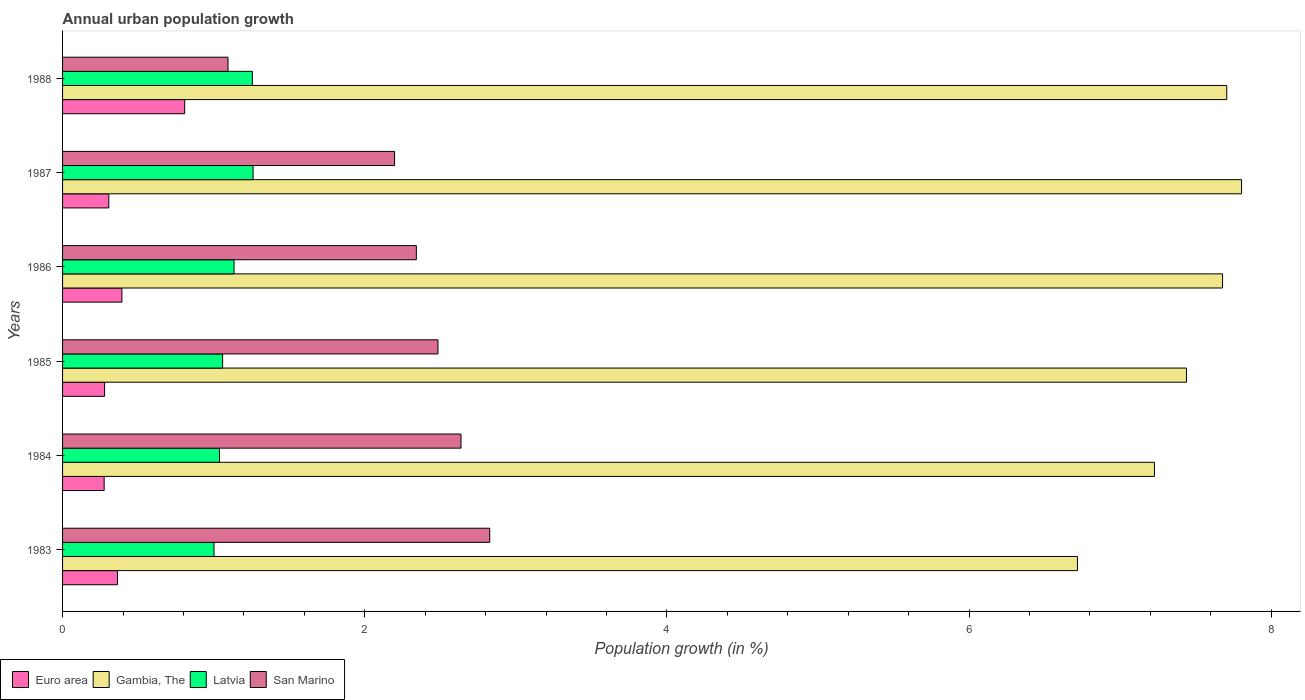How many groups of bars are there?
Keep it short and to the point. 6. Are the number of bars per tick equal to the number of legend labels?
Provide a short and direct response. Yes. Are the number of bars on each tick of the Y-axis equal?
Offer a terse response. Yes. How many bars are there on the 6th tick from the bottom?
Your answer should be very brief. 4. In how many cases, is the number of bars for a given year not equal to the number of legend labels?
Your response must be concise. 0. What is the percentage of urban population growth in Latvia in 1988?
Provide a succinct answer. 1.26. Across all years, what is the maximum percentage of urban population growth in Latvia?
Give a very brief answer. 1.26. Across all years, what is the minimum percentage of urban population growth in Euro area?
Give a very brief answer. 0.28. In which year was the percentage of urban population growth in San Marino maximum?
Provide a succinct answer. 1983. What is the total percentage of urban population growth in Euro area in the graph?
Provide a short and direct response. 2.42. What is the difference between the percentage of urban population growth in Euro area in 1983 and that in 1986?
Make the answer very short. -0.03. What is the difference between the percentage of urban population growth in Gambia, The in 1987 and the percentage of urban population growth in San Marino in 1988?
Ensure brevity in your answer.  6.71. What is the average percentage of urban population growth in Latvia per year?
Offer a terse response. 1.13. In the year 1985, what is the difference between the percentage of urban population growth in Gambia, The and percentage of urban population growth in Euro area?
Make the answer very short. 7.16. In how many years, is the percentage of urban population growth in Latvia greater than 7.6 %?
Offer a very short reply. 0. What is the ratio of the percentage of urban population growth in Gambia, The in 1986 to that in 1988?
Your answer should be compact. 1. What is the difference between the highest and the second highest percentage of urban population growth in Latvia?
Offer a very short reply. 0. What is the difference between the highest and the lowest percentage of urban population growth in San Marino?
Provide a succinct answer. 1.73. In how many years, is the percentage of urban population growth in Gambia, The greater than the average percentage of urban population growth in Gambia, The taken over all years?
Ensure brevity in your answer.  4. Is the sum of the percentage of urban population growth in San Marino in 1983 and 1984 greater than the maximum percentage of urban population growth in Euro area across all years?
Make the answer very short. Yes. What does the 2nd bar from the top in 1983 represents?
Keep it short and to the point. Latvia. What does the 3rd bar from the bottom in 1987 represents?
Your response must be concise. Latvia. How many bars are there?
Provide a succinct answer. 24. Are all the bars in the graph horizontal?
Your answer should be compact. Yes. How many years are there in the graph?
Keep it short and to the point. 6. What is the difference between two consecutive major ticks on the X-axis?
Give a very brief answer. 2. Are the values on the major ticks of X-axis written in scientific E-notation?
Your answer should be compact. No. Does the graph contain grids?
Your answer should be very brief. No. How many legend labels are there?
Offer a terse response. 4. What is the title of the graph?
Keep it short and to the point. Annual urban population growth. What is the label or title of the X-axis?
Your answer should be compact. Population growth (in %). What is the Population growth (in %) in Euro area in 1983?
Your response must be concise. 0.36. What is the Population growth (in %) in Gambia, The in 1983?
Provide a succinct answer. 6.72. What is the Population growth (in %) in Latvia in 1983?
Your answer should be compact. 1. What is the Population growth (in %) in San Marino in 1983?
Your answer should be compact. 2.83. What is the Population growth (in %) in Euro area in 1984?
Your answer should be compact. 0.28. What is the Population growth (in %) of Gambia, The in 1984?
Give a very brief answer. 7.23. What is the Population growth (in %) of Latvia in 1984?
Provide a succinct answer. 1.04. What is the Population growth (in %) in San Marino in 1984?
Your answer should be compact. 2.64. What is the Population growth (in %) in Euro area in 1985?
Your answer should be compact. 0.28. What is the Population growth (in %) of Gambia, The in 1985?
Provide a short and direct response. 7.44. What is the Population growth (in %) of Latvia in 1985?
Make the answer very short. 1.06. What is the Population growth (in %) in San Marino in 1985?
Your answer should be compact. 2.48. What is the Population growth (in %) of Euro area in 1986?
Make the answer very short. 0.39. What is the Population growth (in %) of Gambia, The in 1986?
Ensure brevity in your answer.  7.68. What is the Population growth (in %) of Latvia in 1986?
Ensure brevity in your answer.  1.14. What is the Population growth (in %) in San Marino in 1986?
Your answer should be very brief. 2.34. What is the Population growth (in %) of Euro area in 1987?
Provide a short and direct response. 0.31. What is the Population growth (in %) of Gambia, The in 1987?
Keep it short and to the point. 7.8. What is the Population growth (in %) in Latvia in 1987?
Make the answer very short. 1.26. What is the Population growth (in %) of San Marino in 1987?
Keep it short and to the point. 2.2. What is the Population growth (in %) in Euro area in 1988?
Offer a very short reply. 0.81. What is the Population growth (in %) of Gambia, The in 1988?
Your answer should be compact. 7.71. What is the Population growth (in %) in Latvia in 1988?
Your response must be concise. 1.26. What is the Population growth (in %) of San Marino in 1988?
Keep it short and to the point. 1.1. Across all years, what is the maximum Population growth (in %) of Euro area?
Your response must be concise. 0.81. Across all years, what is the maximum Population growth (in %) in Gambia, The?
Provide a succinct answer. 7.8. Across all years, what is the maximum Population growth (in %) in Latvia?
Provide a short and direct response. 1.26. Across all years, what is the maximum Population growth (in %) of San Marino?
Keep it short and to the point. 2.83. Across all years, what is the minimum Population growth (in %) of Euro area?
Give a very brief answer. 0.28. Across all years, what is the minimum Population growth (in %) in Gambia, The?
Provide a short and direct response. 6.72. Across all years, what is the minimum Population growth (in %) of Latvia?
Your answer should be compact. 1. Across all years, what is the minimum Population growth (in %) in San Marino?
Your answer should be compact. 1.1. What is the total Population growth (in %) of Euro area in the graph?
Your answer should be compact. 2.42. What is the total Population growth (in %) of Gambia, The in the graph?
Your answer should be compact. 44.57. What is the total Population growth (in %) of Latvia in the graph?
Keep it short and to the point. 6.75. What is the total Population growth (in %) in San Marino in the graph?
Offer a terse response. 13.58. What is the difference between the Population growth (in %) of Euro area in 1983 and that in 1984?
Offer a very short reply. 0.09. What is the difference between the Population growth (in %) in Gambia, The in 1983 and that in 1984?
Ensure brevity in your answer.  -0.51. What is the difference between the Population growth (in %) in Latvia in 1983 and that in 1984?
Your answer should be compact. -0.04. What is the difference between the Population growth (in %) of San Marino in 1983 and that in 1984?
Provide a succinct answer. 0.19. What is the difference between the Population growth (in %) in Euro area in 1983 and that in 1985?
Your answer should be very brief. 0.09. What is the difference between the Population growth (in %) of Gambia, The in 1983 and that in 1985?
Offer a terse response. -0.72. What is the difference between the Population growth (in %) in Latvia in 1983 and that in 1985?
Your response must be concise. -0.06. What is the difference between the Population growth (in %) in San Marino in 1983 and that in 1985?
Provide a succinct answer. 0.34. What is the difference between the Population growth (in %) in Euro area in 1983 and that in 1986?
Offer a very short reply. -0.03. What is the difference between the Population growth (in %) of Gambia, The in 1983 and that in 1986?
Keep it short and to the point. -0.96. What is the difference between the Population growth (in %) of Latvia in 1983 and that in 1986?
Your response must be concise. -0.13. What is the difference between the Population growth (in %) in San Marino in 1983 and that in 1986?
Offer a terse response. 0.49. What is the difference between the Population growth (in %) of Euro area in 1983 and that in 1987?
Offer a terse response. 0.06. What is the difference between the Population growth (in %) in Gambia, The in 1983 and that in 1987?
Your answer should be compact. -1.09. What is the difference between the Population growth (in %) in Latvia in 1983 and that in 1987?
Keep it short and to the point. -0.26. What is the difference between the Population growth (in %) in San Marino in 1983 and that in 1987?
Provide a succinct answer. 0.63. What is the difference between the Population growth (in %) in Euro area in 1983 and that in 1988?
Keep it short and to the point. -0.44. What is the difference between the Population growth (in %) in Gambia, The in 1983 and that in 1988?
Ensure brevity in your answer.  -0.99. What is the difference between the Population growth (in %) of Latvia in 1983 and that in 1988?
Give a very brief answer. -0.25. What is the difference between the Population growth (in %) in San Marino in 1983 and that in 1988?
Provide a short and direct response. 1.73. What is the difference between the Population growth (in %) of Euro area in 1984 and that in 1985?
Your response must be concise. -0. What is the difference between the Population growth (in %) of Gambia, The in 1984 and that in 1985?
Your response must be concise. -0.21. What is the difference between the Population growth (in %) in Latvia in 1984 and that in 1985?
Your answer should be compact. -0.02. What is the difference between the Population growth (in %) in San Marino in 1984 and that in 1985?
Your response must be concise. 0.15. What is the difference between the Population growth (in %) in Euro area in 1984 and that in 1986?
Provide a short and direct response. -0.12. What is the difference between the Population growth (in %) of Gambia, The in 1984 and that in 1986?
Your answer should be very brief. -0.45. What is the difference between the Population growth (in %) in Latvia in 1984 and that in 1986?
Keep it short and to the point. -0.1. What is the difference between the Population growth (in %) of San Marino in 1984 and that in 1986?
Ensure brevity in your answer.  0.3. What is the difference between the Population growth (in %) of Euro area in 1984 and that in 1987?
Provide a succinct answer. -0.03. What is the difference between the Population growth (in %) in Gambia, The in 1984 and that in 1987?
Ensure brevity in your answer.  -0.58. What is the difference between the Population growth (in %) in Latvia in 1984 and that in 1987?
Provide a short and direct response. -0.22. What is the difference between the Population growth (in %) in San Marino in 1984 and that in 1987?
Give a very brief answer. 0.44. What is the difference between the Population growth (in %) of Euro area in 1984 and that in 1988?
Your answer should be compact. -0.53. What is the difference between the Population growth (in %) in Gambia, The in 1984 and that in 1988?
Ensure brevity in your answer.  -0.48. What is the difference between the Population growth (in %) of Latvia in 1984 and that in 1988?
Give a very brief answer. -0.22. What is the difference between the Population growth (in %) in San Marino in 1984 and that in 1988?
Offer a terse response. 1.54. What is the difference between the Population growth (in %) of Euro area in 1985 and that in 1986?
Your response must be concise. -0.11. What is the difference between the Population growth (in %) in Gambia, The in 1985 and that in 1986?
Offer a terse response. -0.24. What is the difference between the Population growth (in %) of Latvia in 1985 and that in 1986?
Give a very brief answer. -0.08. What is the difference between the Population growth (in %) in San Marino in 1985 and that in 1986?
Your answer should be compact. 0.14. What is the difference between the Population growth (in %) of Euro area in 1985 and that in 1987?
Your answer should be very brief. -0.03. What is the difference between the Population growth (in %) of Gambia, The in 1985 and that in 1987?
Offer a very short reply. -0.36. What is the difference between the Population growth (in %) in Latvia in 1985 and that in 1987?
Your answer should be very brief. -0.2. What is the difference between the Population growth (in %) of San Marino in 1985 and that in 1987?
Provide a succinct answer. 0.29. What is the difference between the Population growth (in %) in Euro area in 1985 and that in 1988?
Keep it short and to the point. -0.53. What is the difference between the Population growth (in %) in Gambia, The in 1985 and that in 1988?
Offer a very short reply. -0.27. What is the difference between the Population growth (in %) of Latvia in 1985 and that in 1988?
Your answer should be very brief. -0.2. What is the difference between the Population growth (in %) in San Marino in 1985 and that in 1988?
Provide a short and direct response. 1.39. What is the difference between the Population growth (in %) in Euro area in 1986 and that in 1987?
Offer a very short reply. 0.09. What is the difference between the Population growth (in %) of Gambia, The in 1986 and that in 1987?
Your answer should be very brief. -0.13. What is the difference between the Population growth (in %) in Latvia in 1986 and that in 1987?
Make the answer very short. -0.13. What is the difference between the Population growth (in %) in San Marino in 1986 and that in 1987?
Your response must be concise. 0.14. What is the difference between the Population growth (in %) of Euro area in 1986 and that in 1988?
Keep it short and to the point. -0.42. What is the difference between the Population growth (in %) of Gambia, The in 1986 and that in 1988?
Ensure brevity in your answer.  -0.03. What is the difference between the Population growth (in %) of Latvia in 1986 and that in 1988?
Make the answer very short. -0.12. What is the difference between the Population growth (in %) in San Marino in 1986 and that in 1988?
Make the answer very short. 1.25. What is the difference between the Population growth (in %) of Euro area in 1987 and that in 1988?
Keep it short and to the point. -0.5. What is the difference between the Population growth (in %) of Gambia, The in 1987 and that in 1988?
Offer a terse response. 0.1. What is the difference between the Population growth (in %) of Latvia in 1987 and that in 1988?
Your answer should be very brief. 0. What is the difference between the Population growth (in %) in San Marino in 1987 and that in 1988?
Offer a terse response. 1.1. What is the difference between the Population growth (in %) in Euro area in 1983 and the Population growth (in %) in Gambia, The in 1984?
Your answer should be compact. -6.86. What is the difference between the Population growth (in %) in Euro area in 1983 and the Population growth (in %) in Latvia in 1984?
Give a very brief answer. -0.68. What is the difference between the Population growth (in %) of Euro area in 1983 and the Population growth (in %) of San Marino in 1984?
Provide a short and direct response. -2.27. What is the difference between the Population growth (in %) of Gambia, The in 1983 and the Population growth (in %) of Latvia in 1984?
Give a very brief answer. 5.68. What is the difference between the Population growth (in %) of Gambia, The in 1983 and the Population growth (in %) of San Marino in 1984?
Your answer should be very brief. 4.08. What is the difference between the Population growth (in %) of Latvia in 1983 and the Population growth (in %) of San Marino in 1984?
Your answer should be very brief. -1.63. What is the difference between the Population growth (in %) of Euro area in 1983 and the Population growth (in %) of Gambia, The in 1985?
Offer a very short reply. -7.08. What is the difference between the Population growth (in %) in Euro area in 1983 and the Population growth (in %) in Latvia in 1985?
Ensure brevity in your answer.  -0.7. What is the difference between the Population growth (in %) of Euro area in 1983 and the Population growth (in %) of San Marino in 1985?
Give a very brief answer. -2.12. What is the difference between the Population growth (in %) in Gambia, The in 1983 and the Population growth (in %) in Latvia in 1985?
Make the answer very short. 5.66. What is the difference between the Population growth (in %) of Gambia, The in 1983 and the Population growth (in %) of San Marino in 1985?
Ensure brevity in your answer.  4.23. What is the difference between the Population growth (in %) of Latvia in 1983 and the Population growth (in %) of San Marino in 1985?
Your answer should be compact. -1.48. What is the difference between the Population growth (in %) of Euro area in 1983 and the Population growth (in %) of Gambia, The in 1986?
Give a very brief answer. -7.31. What is the difference between the Population growth (in %) of Euro area in 1983 and the Population growth (in %) of Latvia in 1986?
Ensure brevity in your answer.  -0.77. What is the difference between the Population growth (in %) of Euro area in 1983 and the Population growth (in %) of San Marino in 1986?
Your answer should be very brief. -1.98. What is the difference between the Population growth (in %) of Gambia, The in 1983 and the Population growth (in %) of Latvia in 1986?
Your response must be concise. 5.58. What is the difference between the Population growth (in %) of Gambia, The in 1983 and the Population growth (in %) of San Marino in 1986?
Your answer should be very brief. 4.38. What is the difference between the Population growth (in %) of Latvia in 1983 and the Population growth (in %) of San Marino in 1986?
Make the answer very short. -1.34. What is the difference between the Population growth (in %) of Euro area in 1983 and the Population growth (in %) of Gambia, The in 1987?
Give a very brief answer. -7.44. What is the difference between the Population growth (in %) of Euro area in 1983 and the Population growth (in %) of Latvia in 1987?
Keep it short and to the point. -0.9. What is the difference between the Population growth (in %) in Euro area in 1983 and the Population growth (in %) in San Marino in 1987?
Provide a short and direct response. -1.83. What is the difference between the Population growth (in %) of Gambia, The in 1983 and the Population growth (in %) of Latvia in 1987?
Provide a short and direct response. 5.46. What is the difference between the Population growth (in %) of Gambia, The in 1983 and the Population growth (in %) of San Marino in 1987?
Your answer should be compact. 4.52. What is the difference between the Population growth (in %) of Latvia in 1983 and the Population growth (in %) of San Marino in 1987?
Provide a succinct answer. -1.2. What is the difference between the Population growth (in %) in Euro area in 1983 and the Population growth (in %) in Gambia, The in 1988?
Ensure brevity in your answer.  -7.34. What is the difference between the Population growth (in %) in Euro area in 1983 and the Population growth (in %) in Latvia in 1988?
Provide a succinct answer. -0.89. What is the difference between the Population growth (in %) in Euro area in 1983 and the Population growth (in %) in San Marino in 1988?
Provide a short and direct response. -0.73. What is the difference between the Population growth (in %) in Gambia, The in 1983 and the Population growth (in %) in Latvia in 1988?
Your response must be concise. 5.46. What is the difference between the Population growth (in %) of Gambia, The in 1983 and the Population growth (in %) of San Marino in 1988?
Keep it short and to the point. 5.62. What is the difference between the Population growth (in %) in Latvia in 1983 and the Population growth (in %) in San Marino in 1988?
Offer a terse response. -0.09. What is the difference between the Population growth (in %) in Euro area in 1984 and the Population growth (in %) in Gambia, The in 1985?
Offer a terse response. -7.16. What is the difference between the Population growth (in %) in Euro area in 1984 and the Population growth (in %) in Latvia in 1985?
Provide a short and direct response. -0.78. What is the difference between the Population growth (in %) in Euro area in 1984 and the Population growth (in %) in San Marino in 1985?
Your answer should be compact. -2.21. What is the difference between the Population growth (in %) in Gambia, The in 1984 and the Population growth (in %) in Latvia in 1985?
Your response must be concise. 6.17. What is the difference between the Population growth (in %) in Gambia, The in 1984 and the Population growth (in %) in San Marino in 1985?
Your response must be concise. 4.74. What is the difference between the Population growth (in %) of Latvia in 1984 and the Population growth (in %) of San Marino in 1985?
Offer a terse response. -1.45. What is the difference between the Population growth (in %) in Euro area in 1984 and the Population growth (in %) in Gambia, The in 1986?
Give a very brief answer. -7.4. What is the difference between the Population growth (in %) in Euro area in 1984 and the Population growth (in %) in Latvia in 1986?
Offer a terse response. -0.86. What is the difference between the Population growth (in %) in Euro area in 1984 and the Population growth (in %) in San Marino in 1986?
Your response must be concise. -2.07. What is the difference between the Population growth (in %) of Gambia, The in 1984 and the Population growth (in %) of Latvia in 1986?
Give a very brief answer. 6.09. What is the difference between the Population growth (in %) in Gambia, The in 1984 and the Population growth (in %) in San Marino in 1986?
Make the answer very short. 4.89. What is the difference between the Population growth (in %) of Latvia in 1984 and the Population growth (in %) of San Marino in 1986?
Offer a very short reply. -1.3. What is the difference between the Population growth (in %) of Euro area in 1984 and the Population growth (in %) of Gambia, The in 1987?
Make the answer very short. -7.53. What is the difference between the Population growth (in %) in Euro area in 1984 and the Population growth (in %) in Latvia in 1987?
Offer a terse response. -0.99. What is the difference between the Population growth (in %) in Euro area in 1984 and the Population growth (in %) in San Marino in 1987?
Give a very brief answer. -1.92. What is the difference between the Population growth (in %) in Gambia, The in 1984 and the Population growth (in %) in Latvia in 1987?
Make the answer very short. 5.97. What is the difference between the Population growth (in %) of Gambia, The in 1984 and the Population growth (in %) of San Marino in 1987?
Offer a very short reply. 5.03. What is the difference between the Population growth (in %) in Latvia in 1984 and the Population growth (in %) in San Marino in 1987?
Your response must be concise. -1.16. What is the difference between the Population growth (in %) in Euro area in 1984 and the Population growth (in %) in Gambia, The in 1988?
Make the answer very short. -7.43. What is the difference between the Population growth (in %) in Euro area in 1984 and the Population growth (in %) in Latvia in 1988?
Ensure brevity in your answer.  -0.98. What is the difference between the Population growth (in %) of Euro area in 1984 and the Population growth (in %) of San Marino in 1988?
Your answer should be very brief. -0.82. What is the difference between the Population growth (in %) of Gambia, The in 1984 and the Population growth (in %) of Latvia in 1988?
Your answer should be very brief. 5.97. What is the difference between the Population growth (in %) of Gambia, The in 1984 and the Population growth (in %) of San Marino in 1988?
Provide a succinct answer. 6.13. What is the difference between the Population growth (in %) in Latvia in 1984 and the Population growth (in %) in San Marino in 1988?
Your answer should be very brief. -0.06. What is the difference between the Population growth (in %) in Euro area in 1985 and the Population growth (in %) in Gambia, The in 1986?
Offer a terse response. -7.4. What is the difference between the Population growth (in %) in Euro area in 1985 and the Population growth (in %) in Latvia in 1986?
Offer a very short reply. -0.86. What is the difference between the Population growth (in %) of Euro area in 1985 and the Population growth (in %) of San Marino in 1986?
Your answer should be very brief. -2.06. What is the difference between the Population growth (in %) in Gambia, The in 1985 and the Population growth (in %) in Latvia in 1986?
Provide a short and direct response. 6.3. What is the difference between the Population growth (in %) of Gambia, The in 1985 and the Population growth (in %) of San Marino in 1986?
Make the answer very short. 5.1. What is the difference between the Population growth (in %) in Latvia in 1985 and the Population growth (in %) in San Marino in 1986?
Your answer should be compact. -1.28. What is the difference between the Population growth (in %) in Euro area in 1985 and the Population growth (in %) in Gambia, The in 1987?
Your answer should be very brief. -7.53. What is the difference between the Population growth (in %) in Euro area in 1985 and the Population growth (in %) in Latvia in 1987?
Make the answer very short. -0.98. What is the difference between the Population growth (in %) of Euro area in 1985 and the Population growth (in %) of San Marino in 1987?
Your response must be concise. -1.92. What is the difference between the Population growth (in %) of Gambia, The in 1985 and the Population growth (in %) of Latvia in 1987?
Give a very brief answer. 6.18. What is the difference between the Population growth (in %) in Gambia, The in 1985 and the Population growth (in %) in San Marino in 1987?
Offer a very short reply. 5.24. What is the difference between the Population growth (in %) of Latvia in 1985 and the Population growth (in %) of San Marino in 1987?
Keep it short and to the point. -1.14. What is the difference between the Population growth (in %) of Euro area in 1985 and the Population growth (in %) of Gambia, The in 1988?
Make the answer very short. -7.43. What is the difference between the Population growth (in %) of Euro area in 1985 and the Population growth (in %) of Latvia in 1988?
Your response must be concise. -0.98. What is the difference between the Population growth (in %) in Euro area in 1985 and the Population growth (in %) in San Marino in 1988?
Your answer should be compact. -0.82. What is the difference between the Population growth (in %) in Gambia, The in 1985 and the Population growth (in %) in Latvia in 1988?
Your answer should be very brief. 6.18. What is the difference between the Population growth (in %) in Gambia, The in 1985 and the Population growth (in %) in San Marino in 1988?
Offer a very short reply. 6.34. What is the difference between the Population growth (in %) of Latvia in 1985 and the Population growth (in %) of San Marino in 1988?
Ensure brevity in your answer.  -0.04. What is the difference between the Population growth (in %) of Euro area in 1986 and the Population growth (in %) of Gambia, The in 1987?
Provide a short and direct response. -7.41. What is the difference between the Population growth (in %) in Euro area in 1986 and the Population growth (in %) in Latvia in 1987?
Provide a succinct answer. -0.87. What is the difference between the Population growth (in %) in Euro area in 1986 and the Population growth (in %) in San Marino in 1987?
Your answer should be compact. -1.8. What is the difference between the Population growth (in %) in Gambia, The in 1986 and the Population growth (in %) in Latvia in 1987?
Your response must be concise. 6.42. What is the difference between the Population growth (in %) in Gambia, The in 1986 and the Population growth (in %) in San Marino in 1987?
Provide a short and direct response. 5.48. What is the difference between the Population growth (in %) of Latvia in 1986 and the Population growth (in %) of San Marino in 1987?
Your answer should be compact. -1.06. What is the difference between the Population growth (in %) of Euro area in 1986 and the Population growth (in %) of Gambia, The in 1988?
Your answer should be very brief. -7.31. What is the difference between the Population growth (in %) in Euro area in 1986 and the Population growth (in %) in Latvia in 1988?
Give a very brief answer. -0.86. What is the difference between the Population growth (in %) of Euro area in 1986 and the Population growth (in %) of San Marino in 1988?
Provide a short and direct response. -0.7. What is the difference between the Population growth (in %) in Gambia, The in 1986 and the Population growth (in %) in Latvia in 1988?
Provide a succinct answer. 6.42. What is the difference between the Population growth (in %) in Gambia, The in 1986 and the Population growth (in %) in San Marino in 1988?
Offer a very short reply. 6.58. What is the difference between the Population growth (in %) of Euro area in 1987 and the Population growth (in %) of Gambia, The in 1988?
Your answer should be compact. -7.4. What is the difference between the Population growth (in %) in Euro area in 1987 and the Population growth (in %) in Latvia in 1988?
Your answer should be very brief. -0.95. What is the difference between the Population growth (in %) in Euro area in 1987 and the Population growth (in %) in San Marino in 1988?
Your answer should be very brief. -0.79. What is the difference between the Population growth (in %) in Gambia, The in 1987 and the Population growth (in %) in Latvia in 1988?
Your response must be concise. 6.55. What is the difference between the Population growth (in %) in Gambia, The in 1987 and the Population growth (in %) in San Marino in 1988?
Provide a short and direct response. 6.71. What is the difference between the Population growth (in %) of Latvia in 1987 and the Population growth (in %) of San Marino in 1988?
Provide a short and direct response. 0.17. What is the average Population growth (in %) in Euro area per year?
Keep it short and to the point. 0.4. What is the average Population growth (in %) in Gambia, The per year?
Give a very brief answer. 7.43. What is the average Population growth (in %) of Latvia per year?
Give a very brief answer. 1.13. What is the average Population growth (in %) of San Marino per year?
Make the answer very short. 2.26. In the year 1983, what is the difference between the Population growth (in %) of Euro area and Population growth (in %) of Gambia, The?
Provide a short and direct response. -6.35. In the year 1983, what is the difference between the Population growth (in %) in Euro area and Population growth (in %) in Latvia?
Provide a succinct answer. -0.64. In the year 1983, what is the difference between the Population growth (in %) in Euro area and Population growth (in %) in San Marino?
Your answer should be very brief. -2.46. In the year 1983, what is the difference between the Population growth (in %) of Gambia, The and Population growth (in %) of Latvia?
Offer a terse response. 5.71. In the year 1983, what is the difference between the Population growth (in %) in Gambia, The and Population growth (in %) in San Marino?
Make the answer very short. 3.89. In the year 1983, what is the difference between the Population growth (in %) of Latvia and Population growth (in %) of San Marino?
Offer a terse response. -1.82. In the year 1984, what is the difference between the Population growth (in %) in Euro area and Population growth (in %) in Gambia, The?
Offer a very short reply. -6.95. In the year 1984, what is the difference between the Population growth (in %) in Euro area and Population growth (in %) in Latvia?
Your answer should be compact. -0.76. In the year 1984, what is the difference between the Population growth (in %) of Euro area and Population growth (in %) of San Marino?
Keep it short and to the point. -2.36. In the year 1984, what is the difference between the Population growth (in %) in Gambia, The and Population growth (in %) in Latvia?
Give a very brief answer. 6.19. In the year 1984, what is the difference between the Population growth (in %) of Gambia, The and Population growth (in %) of San Marino?
Your answer should be compact. 4.59. In the year 1984, what is the difference between the Population growth (in %) in Latvia and Population growth (in %) in San Marino?
Your response must be concise. -1.6. In the year 1985, what is the difference between the Population growth (in %) of Euro area and Population growth (in %) of Gambia, The?
Offer a very short reply. -7.16. In the year 1985, what is the difference between the Population growth (in %) in Euro area and Population growth (in %) in Latvia?
Your response must be concise. -0.78. In the year 1985, what is the difference between the Population growth (in %) in Euro area and Population growth (in %) in San Marino?
Your answer should be very brief. -2.21. In the year 1985, what is the difference between the Population growth (in %) in Gambia, The and Population growth (in %) in Latvia?
Give a very brief answer. 6.38. In the year 1985, what is the difference between the Population growth (in %) of Gambia, The and Population growth (in %) of San Marino?
Offer a terse response. 4.95. In the year 1985, what is the difference between the Population growth (in %) in Latvia and Population growth (in %) in San Marino?
Give a very brief answer. -1.43. In the year 1986, what is the difference between the Population growth (in %) of Euro area and Population growth (in %) of Gambia, The?
Give a very brief answer. -7.28. In the year 1986, what is the difference between the Population growth (in %) of Euro area and Population growth (in %) of Latvia?
Your answer should be compact. -0.74. In the year 1986, what is the difference between the Population growth (in %) of Euro area and Population growth (in %) of San Marino?
Offer a very short reply. -1.95. In the year 1986, what is the difference between the Population growth (in %) of Gambia, The and Population growth (in %) of Latvia?
Offer a terse response. 6.54. In the year 1986, what is the difference between the Population growth (in %) in Gambia, The and Population growth (in %) in San Marino?
Provide a short and direct response. 5.34. In the year 1986, what is the difference between the Population growth (in %) of Latvia and Population growth (in %) of San Marino?
Your response must be concise. -1.21. In the year 1987, what is the difference between the Population growth (in %) in Euro area and Population growth (in %) in Gambia, The?
Your answer should be very brief. -7.5. In the year 1987, what is the difference between the Population growth (in %) in Euro area and Population growth (in %) in Latvia?
Your response must be concise. -0.95. In the year 1987, what is the difference between the Population growth (in %) in Euro area and Population growth (in %) in San Marino?
Your answer should be compact. -1.89. In the year 1987, what is the difference between the Population growth (in %) of Gambia, The and Population growth (in %) of Latvia?
Make the answer very short. 6.54. In the year 1987, what is the difference between the Population growth (in %) of Gambia, The and Population growth (in %) of San Marino?
Give a very brief answer. 5.61. In the year 1987, what is the difference between the Population growth (in %) in Latvia and Population growth (in %) in San Marino?
Your answer should be very brief. -0.94. In the year 1988, what is the difference between the Population growth (in %) of Euro area and Population growth (in %) of Gambia, The?
Offer a very short reply. -6.9. In the year 1988, what is the difference between the Population growth (in %) of Euro area and Population growth (in %) of Latvia?
Give a very brief answer. -0.45. In the year 1988, what is the difference between the Population growth (in %) in Euro area and Population growth (in %) in San Marino?
Provide a succinct answer. -0.29. In the year 1988, what is the difference between the Population growth (in %) of Gambia, The and Population growth (in %) of Latvia?
Give a very brief answer. 6.45. In the year 1988, what is the difference between the Population growth (in %) in Gambia, The and Population growth (in %) in San Marino?
Keep it short and to the point. 6.61. In the year 1988, what is the difference between the Population growth (in %) in Latvia and Population growth (in %) in San Marino?
Offer a very short reply. 0.16. What is the ratio of the Population growth (in %) in Euro area in 1983 to that in 1984?
Offer a terse response. 1.32. What is the ratio of the Population growth (in %) in Gambia, The in 1983 to that in 1984?
Your answer should be compact. 0.93. What is the ratio of the Population growth (in %) in Latvia in 1983 to that in 1984?
Offer a terse response. 0.96. What is the ratio of the Population growth (in %) of San Marino in 1983 to that in 1984?
Provide a succinct answer. 1.07. What is the ratio of the Population growth (in %) in Euro area in 1983 to that in 1985?
Offer a very short reply. 1.31. What is the ratio of the Population growth (in %) of Gambia, The in 1983 to that in 1985?
Your answer should be compact. 0.9. What is the ratio of the Population growth (in %) of Latvia in 1983 to that in 1985?
Offer a terse response. 0.95. What is the ratio of the Population growth (in %) in San Marino in 1983 to that in 1985?
Keep it short and to the point. 1.14. What is the ratio of the Population growth (in %) of Euro area in 1983 to that in 1986?
Give a very brief answer. 0.92. What is the ratio of the Population growth (in %) of Gambia, The in 1983 to that in 1986?
Give a very brief answer. 0.87. What is the ratio of the Population growth (in %) of Latvia in 1983 to that in 1986?
Your answer should be very brief. 0.88. What is the ratio of the Population growth (in %) of San Marino in 1983 to that in 1986?
Make the answer very short. 1.21. What is the ratio of the Population growth (in %) in Euro area in 1983 to that in 1987?
Provide a succinct answer. 1.19. What is the ratio of the Population growth (in %) of Gambia, The in 1983 to that in 1987?
Your answer should be very brief. 0.86. What is the ratio of the Population growth (in %) in Latvia in 1983 to that in 1987?
Offer a very short reply. 0.79. What is the ratio of the Population growth (in %) of San Marino in 1983 to that in 1987?
Provide a succinct answer. 1.29. What is the ratio of the Population growth (in %) in Euro area in 1983 to that in 1988?
Your answer should be compact. 0.45. What is the ratio of the Population growth (in %) of Gambia, The in 1983 to that in 1988?
Make the answer very short. 0.87. What is the ratio of the Population growth (in %) of Latvia in 1983 to that in 1988?
Your response must be concise. 0.8. What is the ratio of the Population growth (in %) in San Marino in 1983 to that in 1988?
Provide a short and direct response. 2.58. What is the ratio of the Population growth (in %) of Euro area in 1984 to that in 1985?
Provide a succinct answer. 0.99. What is the ratio of the Population growth (in %) in Gambia, The in 1984 to that in 1985?
Provide a succinct answer. 0.97. What is the ratio of the Population growth (in %) in Latvia in 1984 to that in 1985?
Make the answer very short. 0.98. What is the ratio of the Population growth (in %) in San Marino in 1984 to that in 1985?
Your response must be concise. 1.06. What is the ratio of the Population growth (in %) in Euro area in 1984 to that in 1986?
Offer a very short reply. 0.7. What is the ratio of the Population growth (in %) in Gambia, The in 1984 to that in 1986?
Your answer should be compact. 0.94. What is the ratio of the Population growth (in %) in Latvia in 1984 to that in 1986?
Ensure brevity in your answer.  0.92. What is the ratio of the Population growth (in %) of San Marino in 1984 to that in 1986?
Provide a succinct answer. 1.13. What is the ratio of the Population growth (in %) of Euro area in 1984 to that in 1987?
Your response must be concise. 0.9. What is the ratio of the Population growth (in %) of Gambia, The in 1984 to that in 1987?
Offer a terse response. 0.93. What is the ratio of the Population growth (in %) in Latvia in 1984 to that in 1987?
Provide a short and direct response. 0.82. What is the ratio of the Population growth (in %) in San Marino in 1984 to that in 1987?
Offer a very short reply. 1.2. What is the ratio of the Population growth (in %) of Euro area in 1984 to that in 1988?
Give a very brief answer. 0.34. What is the ratio of the Population growth (in %) in Gambia, The in 1984 to that in 1988?
Provide a succinct answer. 0.94. What is the ratio of the Population growth (in %) of Latvia in 1984 to that in 1988?
Your response must be concise. 0.83. What is the ratio of the Population growth (in %) of San Marino in 1984 to that in 1988?
Keep it short and to the point. 2.41. What is the ratio of the Population growth (in %) in Euro area in 1985 to that in 1986?
Offer a very short reply. 0.71. What is the ratio of the Population growth (in %) of Gambia, The in 1985 to that in 1986?
Offer a terse response. 0.97. What is the ratio of the Population growth (in %) of Latvia in 1985 to that in 1986?
Your answer should be very brief. 0.93. What is the ratio of the Population growth (in %) of San Marino in 1985 to that in 1986?
Offer a very short reply. 1.06. What is the ratio of the Population growth (in %) in Euro area in 1985 to that in 1987?
Make the answer very short. 0.91. What is the ratio of the Population growth (in %) in Gambia, The in 1985 to that in 1987?
Give a very brief answer. 0.95. What is the ratio of the Population growth (in %) of Latvia in 1985 to that in 1987?
Your answer should be compact. 0.84. What is the ratio of the Population growth (in %) in San Marino in 1985 to that in 1987?
Make the answer very short. 1.13. What is the ratio of the Population growth (in %) in Euro area in 1985 to that in 1988?
Your answer should be compact. 0.34. What is the ratio of the Population growth (in %) in Gambia, The in 1985 to that in 1988?
Your answer should be very brief. 0.97. What is the ratio of the Population growth (in %) of Latvia in 1985 to that in 1988?
Offer a very short reply. 0.84. What is the ratio of the Population growth (in %) of San Marino in 1985 to that in 1988?
Offer a terse response. 2.27. What is the ratio of the Population growth (in %) of Euro area in 1986 to that in 1987?
Give a very brief answer. 1.28. What is the ratio of the Population growth (in %) in Gambia, The in 1986 to that in 1987?
Keep it short and to the point. 0.98. What is the ratio of the Population growth (in %) of Latvia in 1986 to that in 1987?
Ensure brevity in your answer.  0.9. What is the ratio of the Population growth (in %) in San Marino in 1986 to that in 1987?
Keep it short and to the point. 1.07. What is the ratio of the Population growth (in %) in Euro area in 1986 to that in 1988?
Your answer should be very brief. 0.49. What is the ratio of the Population growth (in %) in Gambia, The in 1986 to that in 1988?
Make the answer very short. 1. What is the ratio of the Population growth (in %) in Latvia in 1986 to that in 1988?
Keep it short and to the point. 0.9. What is the ratio of the Population growth (in %) of San Marino in 1986 to that in 1988?
Make the answer very short. 2.14. What is the ratio of the Population growth (in %) in Euro area in 1987 to that in 1988?
Your answer should be very brief. 0.38. What is the ratio of the Population growth (in %) in Gambia, The in 1987 to that in 1988?
Provide a succinct answer. 1.01. What is the ratio of the Population growth (in %) in San Marino in 1987 to that in 1988?
Provide a succinct answer. 2.01. What is the difference between the highest and the second highest Population growth (in %) in Euro area?
Offer a terse response. 0.42. What is the difference between the highest and the second highest Population growth (in %) of Gambia, The?
Make the answer very short. 0.1. What is the difference between the highest and the second highest Population growth (in %) of Latvia?
Your answer should be very brief. 0. What is the difference between the highest and the second highest Population growth (in %) in San Marino?
Your answer should be very brief. 0.19. What is the difference between the highest and the lowest Population growth (in %) in Euro area?
Provide a succinct answer. 0.53. What is the difference between the highest and the lowest Population growth (in %) in Gambia, The?
Keep it short and to the point. 1.09. What is the difference between the highest and the lowest Population growth (in %) in Latvia?
Offer a terse response. 0.26. What is the difference between the highest and the lowest Population growth (in %) of San Marino?
Keep it short and to the point. 1.73. 